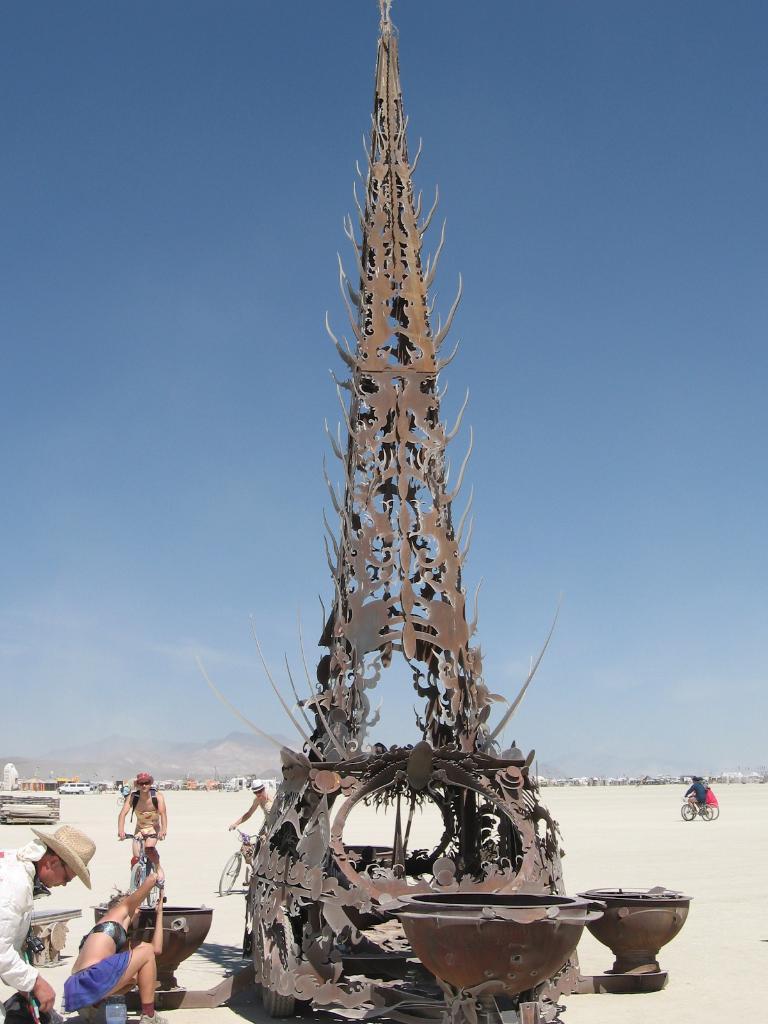How would you summarize this image in a sentence or two? In this image we can see some people and among them few people riding bicycles and there is a structure which looks like a statue in the middle of the image. We can see some other objects and we can see the sky in the background. 